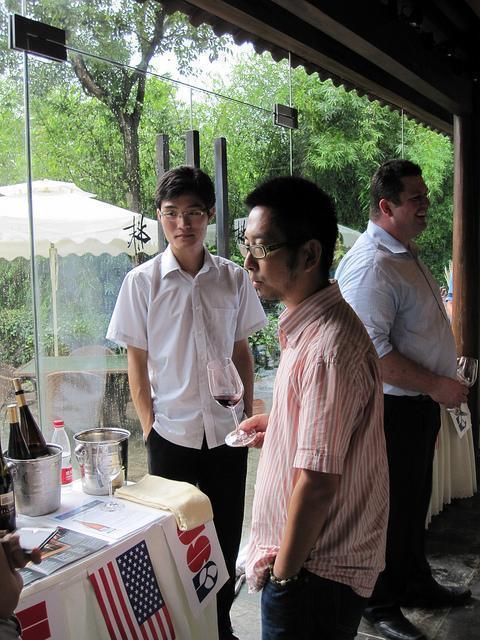What do two of the three men have on?
Indicate the correct response by choosing from the four available options to answer the question.
Options: Glasses, tie, shirt, pants. Glasses. 